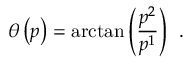Convert formula to latex. <formula><loc_0><loc_0><loc_500><loc_500>\theta \left ( p \right ) = \arctan \left ( \frac { p ^ { 2 } } { p ^ { 1 } } \right ) \, .</formula> 